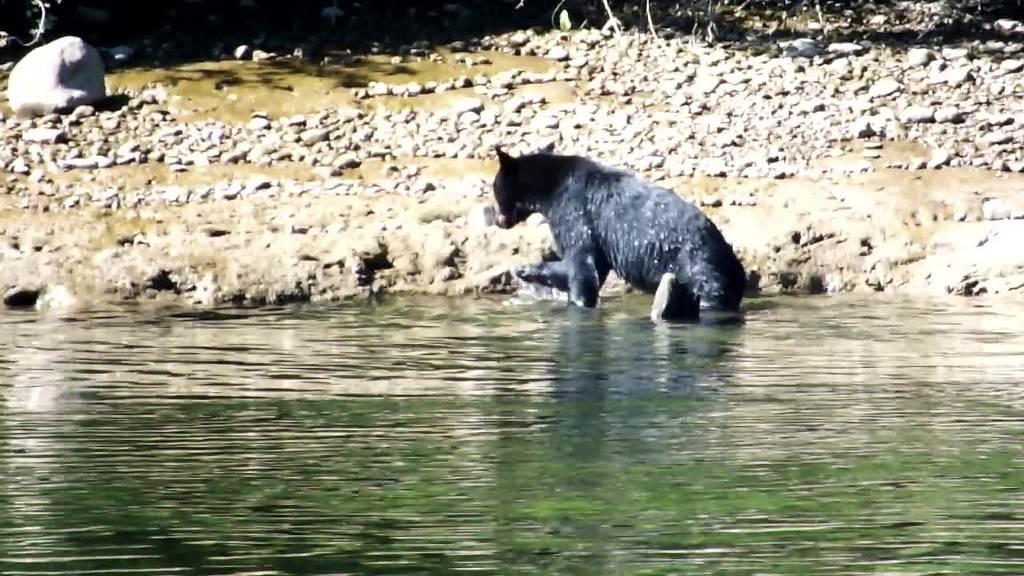What is on the surface of the water in the image? There is an animal on the surface of the water in the image. Can you describe the land in the background of the image? There are stones visible on the land in the background of the image. How many legs can be seen on the desk in the image? There is no desk present in the image, so it is not possible to determine the number of legs. 